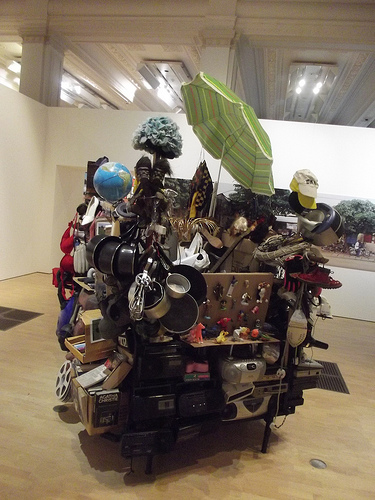<image>
Can you confirm if the umbrella is on the cart? Yes. Looking at the image, I can see the umbrella is positioned on top of the cart, with the cart providing support. Where is the umbrella in relation to the egg beater? Is it above the egg beater? Yes. The umbrella is positioned above the egg beater in the vertical space, higher up in the scene. 